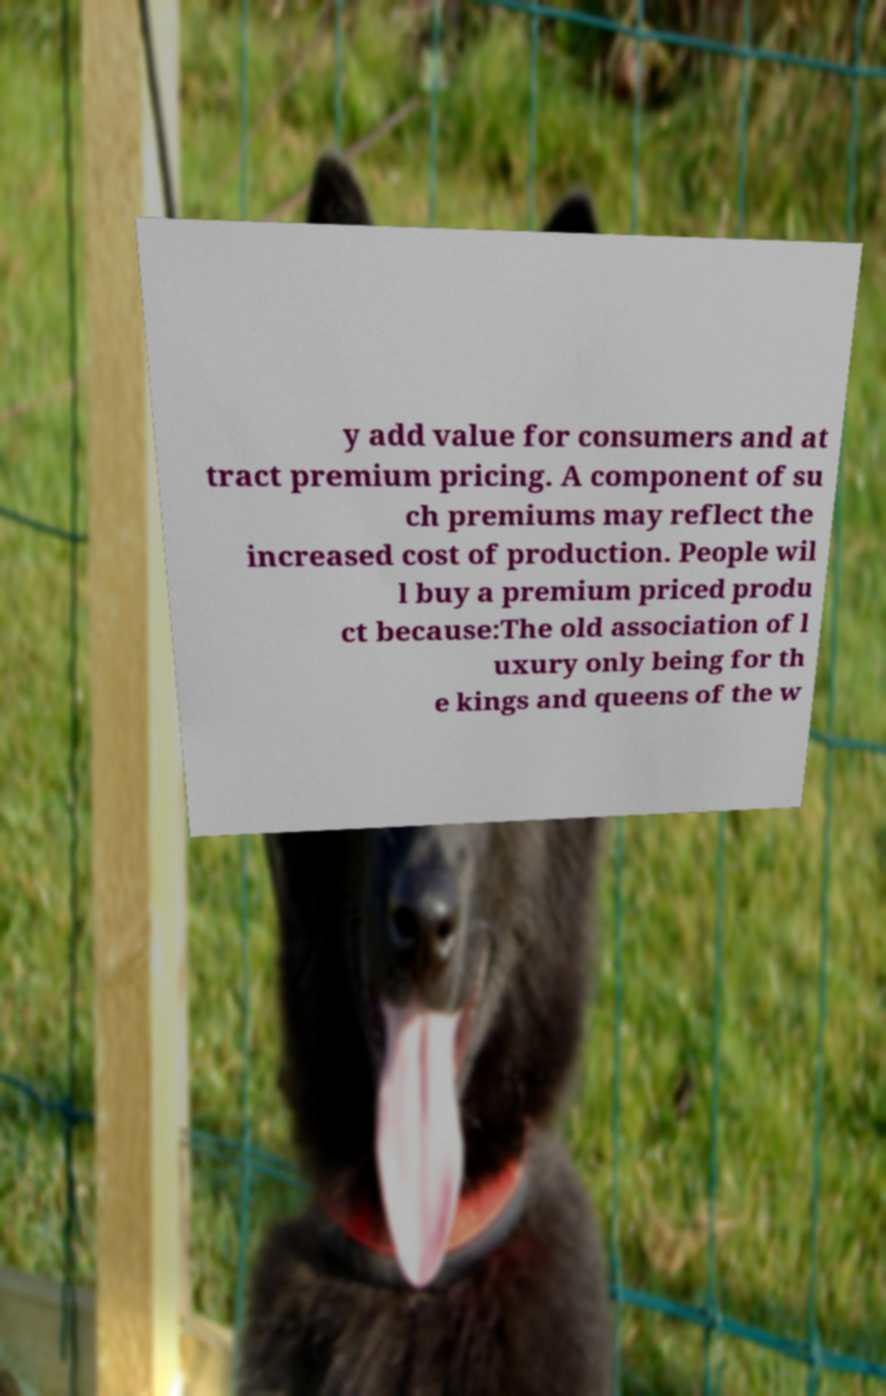I need the written content from this picture converted into text. Can you do that? y add value for consumers and at tract premium pricing. A component of su ch premiums may reflect the increased cost of production. People wil l buy a premium priced produ ct because:The old association of l uxury only being for th e kings and queens of the w 